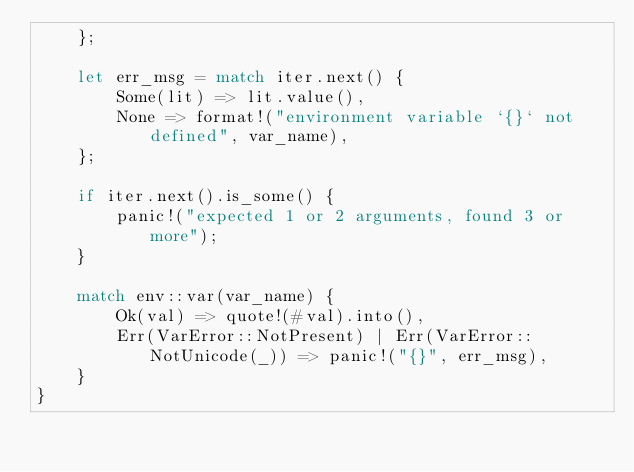Convert code to text. <code><loc_0><loc_0><loc_500><loc_500><_Rust_>    };

    let err_msg = match iter.next() {
        Some(lit) => lit.value(),
        None => format!("environment variable `{}` not defined", var_name),
    };

    if iter.next().is_some() {
        panic!("expected 1 or 2 arguments, found 3 or more");
    }

    match env::var(var_name) {
        Ok(val) => quote!(#val).into(),
        Err(VarError::NotPresent) | Err(VarError::NotUnicode(_)) => panic!("{}", err_msg),
    }
}
</code> 